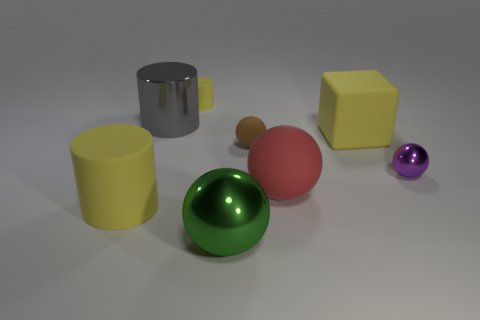Is there a small purple thing of the same shape as the small brown matte thing?
Provide a short and direct response. Yes. What is the shape of the purple shiny object?
Your answer should be compact. Sphere. Is the number of gray metallic objects that are right of the gray metallic object greater than the number of small yellow cylinders in front of the yellow block?
Offer a terse response. No. How many other objects are the same size as the gray shiny object?
Make the answer very short. 4. What material is the big thing that is behind the tiny matte ball and to the left of the big metallic sphere?
Your response must be concise. Metal. There is a large yellow object that is the same shape as the gray object; what is its material?
Offer a terse response. Rubber. How many large yellow rubber blocks are on the left side of the big yellow thing that is to the right of the yellow cylinder that is in front of the large yellow matte cube?
Your answer should be compact. 0. Is there any other thing that has the same color as the big rubber ball?
Provide a short and direct response. No. How many small objects are both to the right of the large red matte ball and behind the gray cylinder?
Provide a short and direct response. 0. There is a rubber cylinder that is in front of the purple object; does it have the same size as the red thing on the left side of the small metal ball?
Ensure brevity in your answer.  Yes. 